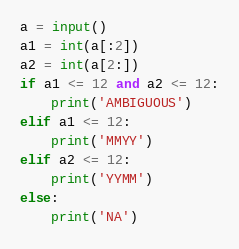<code> <loc_0><loc_0><loc_500><loc_500><_Python_>a = input()
a1 = int(a[:2])
a2 = int(a[2:])
if a1 <= 12 and a2 <= 12:
    print('AMBIGUOUS')
elif a1 <= 12:
    print('MMYY')
elif a2 <= 12:
    print('YYMM')
else:
    print('NA')</code> 